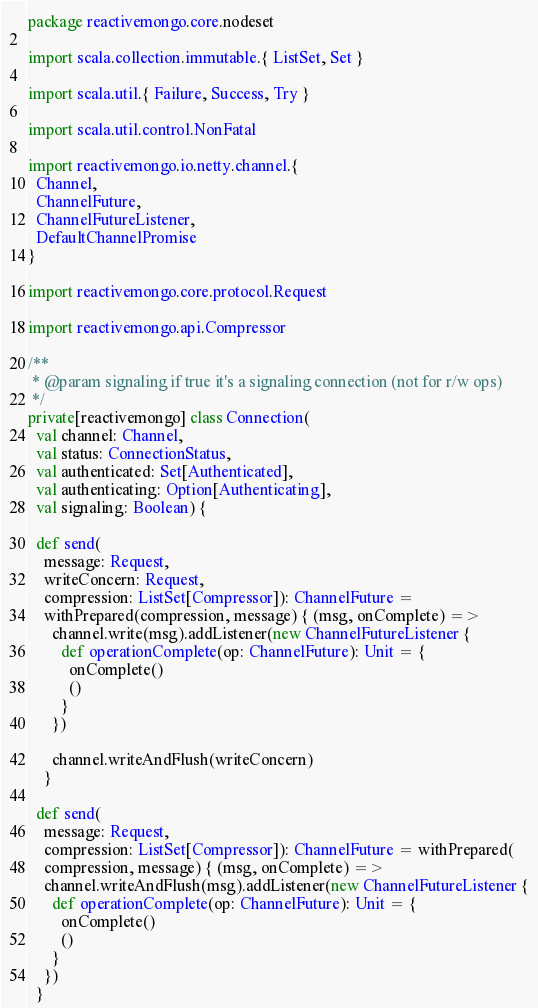<code> <loc_0><loc_0><loc_500><loc_500><_Scala_>package reactivemongo.core.nodeset

import scala.collection.immutable.{ ListSet, Set }

import scala.util.{ Failure, Success, Try }

import scala.util.control.NonFatal

import reactivemongo.io.netty.channel.{
  Channel,
  ChannelFuture,
  ChannelFutureListener,
  DefaultChannelPromise
}

import reactivemongo.core.protocol.Request

import reactivemongo.api.Compressor

/**
 * @param signaling if true it's a signaling connection (not for r/w ops)
 */
private[reactivemongo] class Connection(
  val channel: Channel,
  val status: ConnectionStatus,
  val authenticated: Set[Authenticated],
  val authenticating: Option[Authenticating],
  val signaling: Boolean) {

  def send(
    message: Request,
    writeConcern: Request,
    compression: ListSet[Compressor]): ChannelFuture =
    withPrepared(compression, message) { (msg, onComplete) =>
      channel.write(msg).addListener(new ChannelFutureListener {
        def operationComplete(op: ChannelFuture): Unit = {
          onComplete()
          ()
        }
      })

      channel.writeAndFlush(writeConcern)
    }

  def send(
    message: Request,
    compression: ListSet[Compressor]): ChannelFuture = withPrepared(
    compression, message) { (msg, onComplete) =>
    channel.writeAndFlush(msg).addListener(new ChannelFutureListener {
      def operationComplete(op: ChannelFuture): Unit = {
        onComplete()
        ()
      }
    })
  }
</code> 